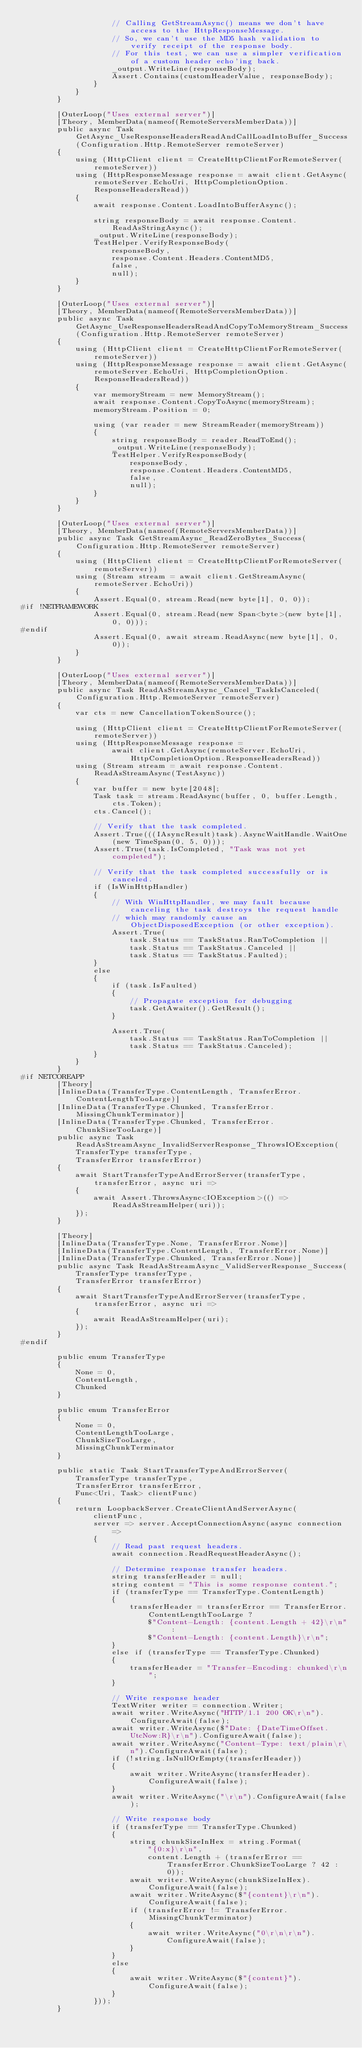<code> <loc_0><loc_0><loc_500><loc_500><_C#_>                    // Calling GetStreamAsync() means we don't have access to the HttpResponseMessage.
                    // So, we can't use the MD5 hash validation to verify receipt of the response body.
                    // For this test, we can use a simpler verification of a custom header echo'ing back.
                    _output.WriteLine(responseBody);
                    Assert.Contains(customHeaderValue, responseBody);
                }
            }
        }

        [OuterLoop("Uses external server")]
        [Theory, MemberData(nameof(RemoteServersMemberData))]
        public async Task GetAsync_UseResponseHeadersReadAndCallLoadIntoBuffer_Success(Configuration.Http.RemoteServer remoteServer)
        {
            using (HttpClient client = CreateHttpClientForRemoteServer(remoteServer))
            using (HttpResponseMessage response = await client.GetAsync(remoteServer.EchoUri, HttpCompletionOption.ResponseHeadersRead))
            {
                await response.Content.LoadIntoBufferAsync();

                string responseBody = await response.Content.ReadAsStringAsync();
                _output.WriteLine(responseBody);
                TestHelper.VerifyResponseBody(
                    responseBody,
                    response.Content.Headers.ContentMD5,
                    false,
                    null);
            }
        }

        [OuterLoop("Uses external server")]
        [Theory, MemberData(nameof(RemoteServersMemberData))]
        public async Task GetAsync_UseResponseHeadersReadAndCopyToMemoryStream_Success(Configuration.Http.RemoteServer remoteServer)
        {
            using (HttpClient client = CreateHttpClientForRemoteServer(remoteServer))
            using (HttpResponseMessage response = await client.GetAsync(remoteServer.EchoUri, HttpCompletionOption.ResponseHeadersRead))
            {
                var memoryStream = new MemoryStream();
                await response.Content.CopyToAsync(memoryStream);
                memoryStream.Position = 0;

                using (var reader = new StreamReader(memoryStream))
                {
                    string responseBody = reader.ReadToEnd();
                    _output.WriteLine(responseBody);
                    TestHelper.VerifyResponseBody(
                        responseBody,
                        response.Content.Headers.ContentMD5,
                        false,
                        null);
                }
            }
        }

        [OuterLoop("Uses external server")]
        [Theory, MemberData(nameof(RemoteServersMemberData))]
        public async Task GetStreamAsync_ReadZeroBytes_Success(Configuration.Http.RemoteServer remoteServer)
        {
            using (HttpClient client = CreateHttpClientForRemoteServer(remoteServer))
            using (Stream stream = await client.GetStreamAsync(remoteServer.EchoUri))
            {
                Assert.Equal(0, stream.Read(new byte[1], 0, 0));
#if !NETFRAMEWORK
                Assert.Equal(0, stream.Read(new Span<byte>(new byte[1], 0, 0)));
#endif
                Assert.Equal(0, await stream.ReadAsync(new byte[1], 0, 0));
            }
        }

        [OuterLoop("Uses external server")]
        [Theory, MemberData(nameof(RemoteServersMemberData))]
        public async Task ReadAsStreamAsync_Cancel_TaskIsCanceled(Configuration.Http.RemoteServer remoteServer)
        {
            var cts = new CancellationTokenSource();

            using (HttpClient client = CreateHttpClientForRemoteServer(remoteServer))
            using (HttpResponseMessage response =
                    await client.GetAsync(remoteServer.EchoUri, HttpCompletionOption.ResponseHeadersRead))
            using (Stream stream = await response.Content.ReadAsStreamAsync(TestAsync))
            {
                var buffer = new byte[2048];
                Task task = stream.ReadAsync(buffer, 0, buffer.Length, cts.Token);
                cts.Cancel();

                // Verify that the task completed.
                Assert.True(((IAsyncResult)task).AsyncWaitHandle.WaitOne(new TimeSpan(0, 5, 0)));
                Assert.True(task.IsCompleted, "Task was not yet completed");

                // Verify that the task completed successfully or is canceled.
                if (IsWinHttpHandler)
                {
                    // With WinHttpHandler, we may fault because canceling the task destroys the request handle
                    // which may randomly cause an ObjectDisposedException (or other exception).
                    Assert.True(
                        task.Status == TaskStatus.RanToCompletion ||
                        task.Status == TaskStatus.Canceled ||
                        task.Status == TaskStatus.Faulted);
                }
                else
                {
                    if (task.IsFaulted)
                    {
                        // Propagate exception for debugging
                        task.GetAwaiter().GetResult();
                    }

                    Assert.True(
                        task.Status == TaskStatus.RanToCompletion ||
                        task.Status == TaskStatus.Canceled);
                }
            }
        }
#if NETCOREAPP
        [Theory]
        [InlineData(TransferType.ContentLength, TransferError.ContentLengthTooLarge)]
        [InlineData(TransferType.Chunked, TransferError.MissingChunkTerminator)]
        [InlineData(TransferType.Chunked, TransferError.ChunkSizeTooLarge)]
        public async Task ReadAsStreamAsync_InvalidServerResponse_ThrowsIOException(
            TransferType transferType,
            TransferError transferError)
        {
            await StartTransferTypeAndErrorServer(transferType, transferError, async uri =>
            {
                await Assert.ThrowsAsync<IOException>(() => ReadAsStreamHelper(uri));
            });
        }

        [Theory]
        [InlineData(TransferType.None, TransferError.None)]
        [InlineData(TransferType.ContentLength, TransferError.None)]
        [InlineData(TransferType.Chunked, TransferError.None)]
        public async Task ReadAsStreamAsync_ValidServerResponse_Success(
            TransferType transferType,
            TransferError transferError)
        {
            await StartTransferTypeAndErrorServer(transferType, transferError, async uri =>
            {
                await ReadAsStreamHelper(uri);
            });
        }
#endif

        public enum TransferType
        {
            None = 0,
            ContentLength,
            Chunked
        }

        public enum TransferError
        {
            None = 0,
            ContentLengthTooLarge,
            ChunkSizeTooLarge,
            MissingChunkTerminator
        }

        public static Task StartTransferTypeAndErrorServer(
            TransferType transferType,
            TransferError transferError,
            Func<Uri, Task> clientFunc)
        {
            return LoopbackServer.CreateClientAndServerAsync(
                clientFunc,
                server => server.AcceptConnectionAsync(async connection =>
                {
                    // Read past request headers.
                    await connection.ReadRequestHeaderAsync();

                    // Determine response transfer headers.
                    string transferHeader = null;
                    string content = "This is some response content.";
                    if (transferType == TransferType.ContentLength)
                    {
                        transferHeader = transferError == TransferError.ContentLengthTooLarge ?
                            $"Content-Length: {content.Length + 42}\r\n" :
                            $"Content-Length: {content.Length}\r\n";
                    }
                    else if (transferType == TransferType.Chunked)
                    {
                        transferHeader = "Transfer-Encoding: chunked\r\n";
                    }

                    // Write response header
                    TextWriter writer = connection.Writer;
                    await writer.WriteAsync("HTTP/1.1 200 OK\r\n").ConfigureAwait(false);
                    await writer.WriteAsync($"Date: {DateTimeOffset.UtcNow:R}\r\n").ConfigureAwait(false);
                    await writer.WriteAsync("Content-Type: text/plain\r\n").ConfigureAwait(false);
                    if (!string.IsNullOrEmpty(transferHeader))
                    {
                        await writer.WriteAsync(transferHeader).ConfigureAwait(false);
                    }
                    await writer.WriteAsync("\r\n").ConfigureAwait(false);

                    // Write response body
                    if (transferType == TransferType.Chunked)
                    {
                        string chunkSizeInHex = string.Format(
                            "{0:x}\r\n",
                            content.Length + (transferError == TransferError.ChunkSizeTooLarge ? 42 : 0));
                        await writer.WriteAsync(chunkSizeInHex).ConfigureAwait(false);
                        await writer.WriteAsync($"{content}\r\n").ConfigureAwait(false);
                        if (transferError != TransferError.MissingChunkTerminator)
                        {
                            await writer.WriteAsync("0\r\n\r\n").ConfigureAwait(false);
                        }
                    }
                    else
                    {
                        await writer.WriteAsync($"{content}").ConfigureAwait(false);
                    }
                }));
        }
</code> 